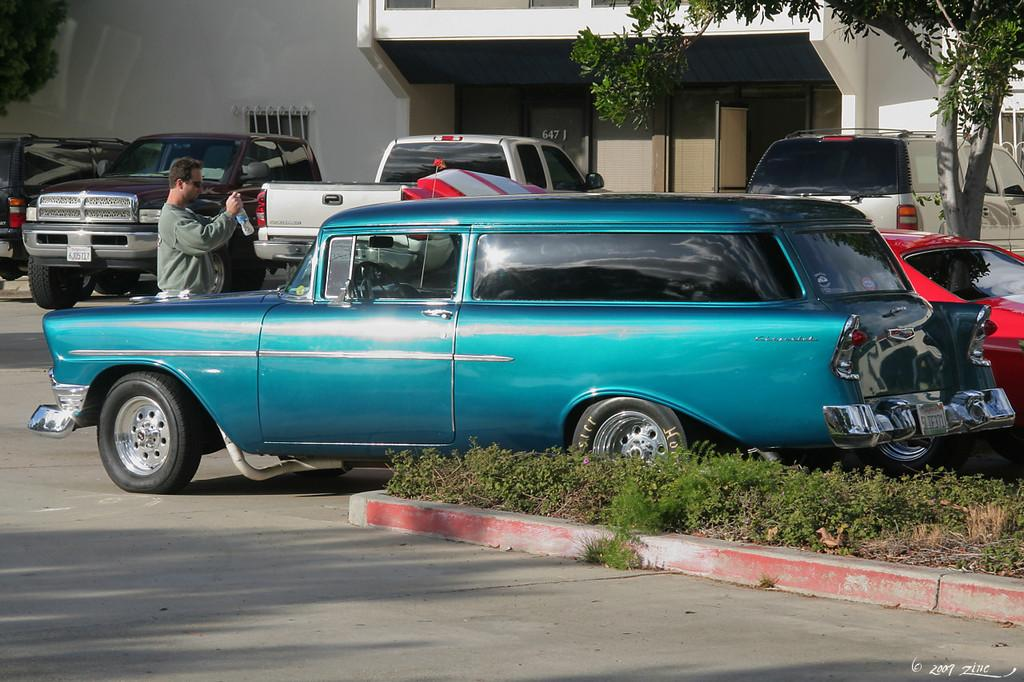What can be seen moving on the road in the image? There are cars on the road in the image. What type of natural elements are visible in the image? There are trees visible in the image. What is the man in the image holding? The man is holding a bottle in the image. Can you describe the man's position in the image? The man is standing in the image. What type of structure can be seen in the background of the image? There is a building with windows in the background of the image. What type of copper material can be seen on the man's clothing in the image? There is no copper material visible on the man's clothing in the image. Can you describe the texture of the bat that is flying in the image? There is no bat present in the image; it only features cars, trees, a man holding a bottle, and a building with windows. 